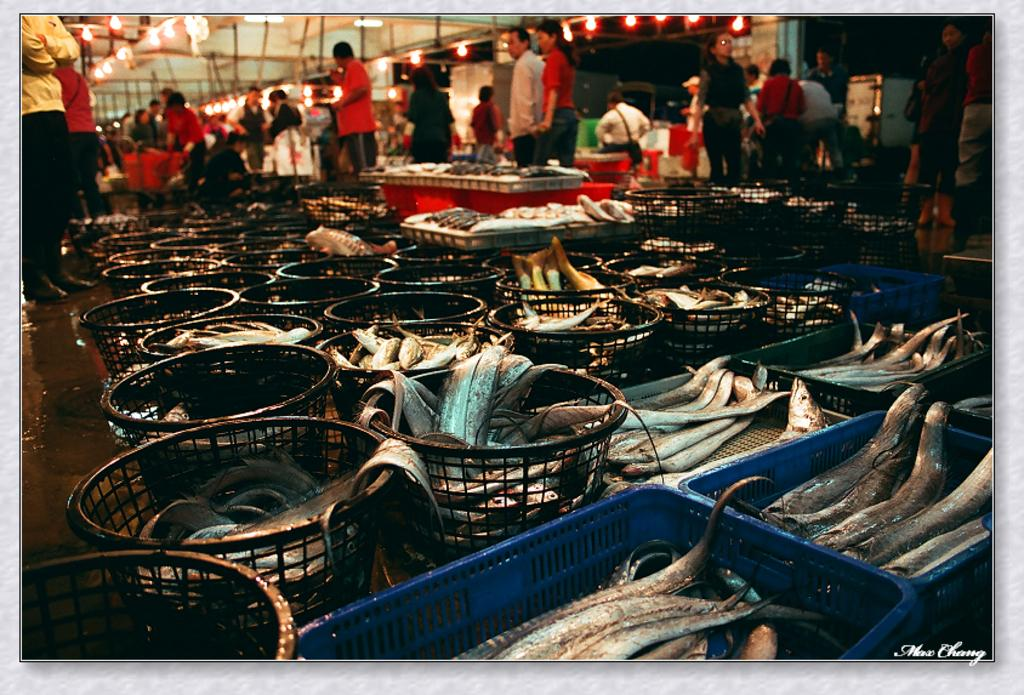What is present in the baskets in the image? There are many fishes in the baskets. Can you describe the background of the image? There are people in the background of the image. What can be seen illuminating the scene in the image? There are lights visible in the image. What is the son arguing about with his father in the image? There is no son or argument present in the image. 